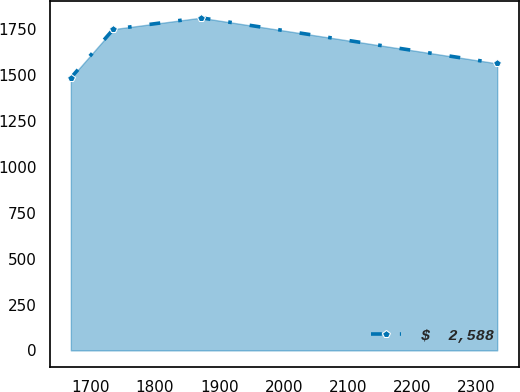Convert chart. <chart><loc_0><loc_0><loc_500><loc_500><line_chart><ecel><fcel>$  2,588<nl><fcel>1669<fcel>1484.58<nl><fcel>1735.32<fcel>1750.12<nl><fcel>1870.82<fcel>1812.02<nl><fcel>2332.21<fcel>1563.32<nl></chart> 